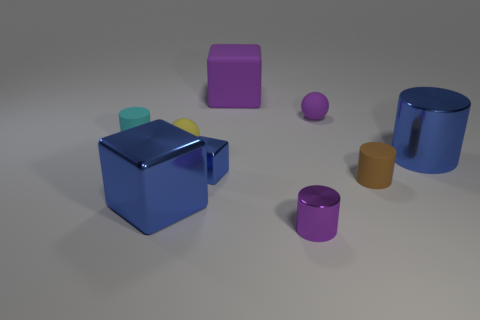How many yellow balls are there?
Your answer should be very brief. 1. Does the rubber cylinder behind the tiny brown rubber thing have the same size as the rubber cylinder that is on the right side of the small blue metallic cube?
Make the answer very short. Yes. The big shiny thing that is the same shape as the large matte thing is what color?
Your answer should be very brief. Blue. Is the shape of the tiny brown rubber thing the same as the purple shiny object?
Keep it short and to the point. Yes. What size is the brown object that is the same shape as the tiny purple metallic thing?
Your answer should be very brief. Small. What number of tiny yellow objects are the same material as the big purple block?
Provide a short and direct response. 1. What number of things are large purple matte objects or cyan rubber cylinders?
Make the answer very short. 2. Is there a cube behind the shiny cylinder that is behind the small purple shiny cylinder?
Give a very brief answer. Yes. Is the number of cylinders that are behind the blue cylinder greater than the number of rubber blocks in front of the big blue block?
Provide a short and direct response. Yes. What is the material of the small cylinder that is the same color as the matte cube?
Offer a terse response. Metal. 